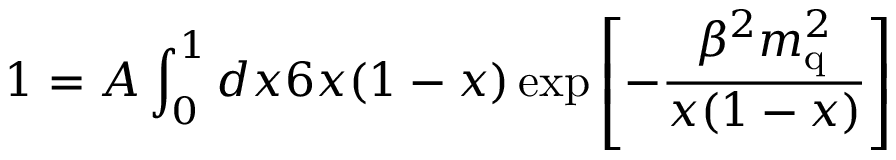<formula> <loc_0><loc_0><loc_500><loc_500>1 = A \int _ { 0 } ^ { 1 } d x 6 x ( 1 - x ) \exp { \left [ - \frac { \beta ^ { 2 } m _ { q } ^ { 2 } } { x ( 1 - x ) } \right ] }</formula> 